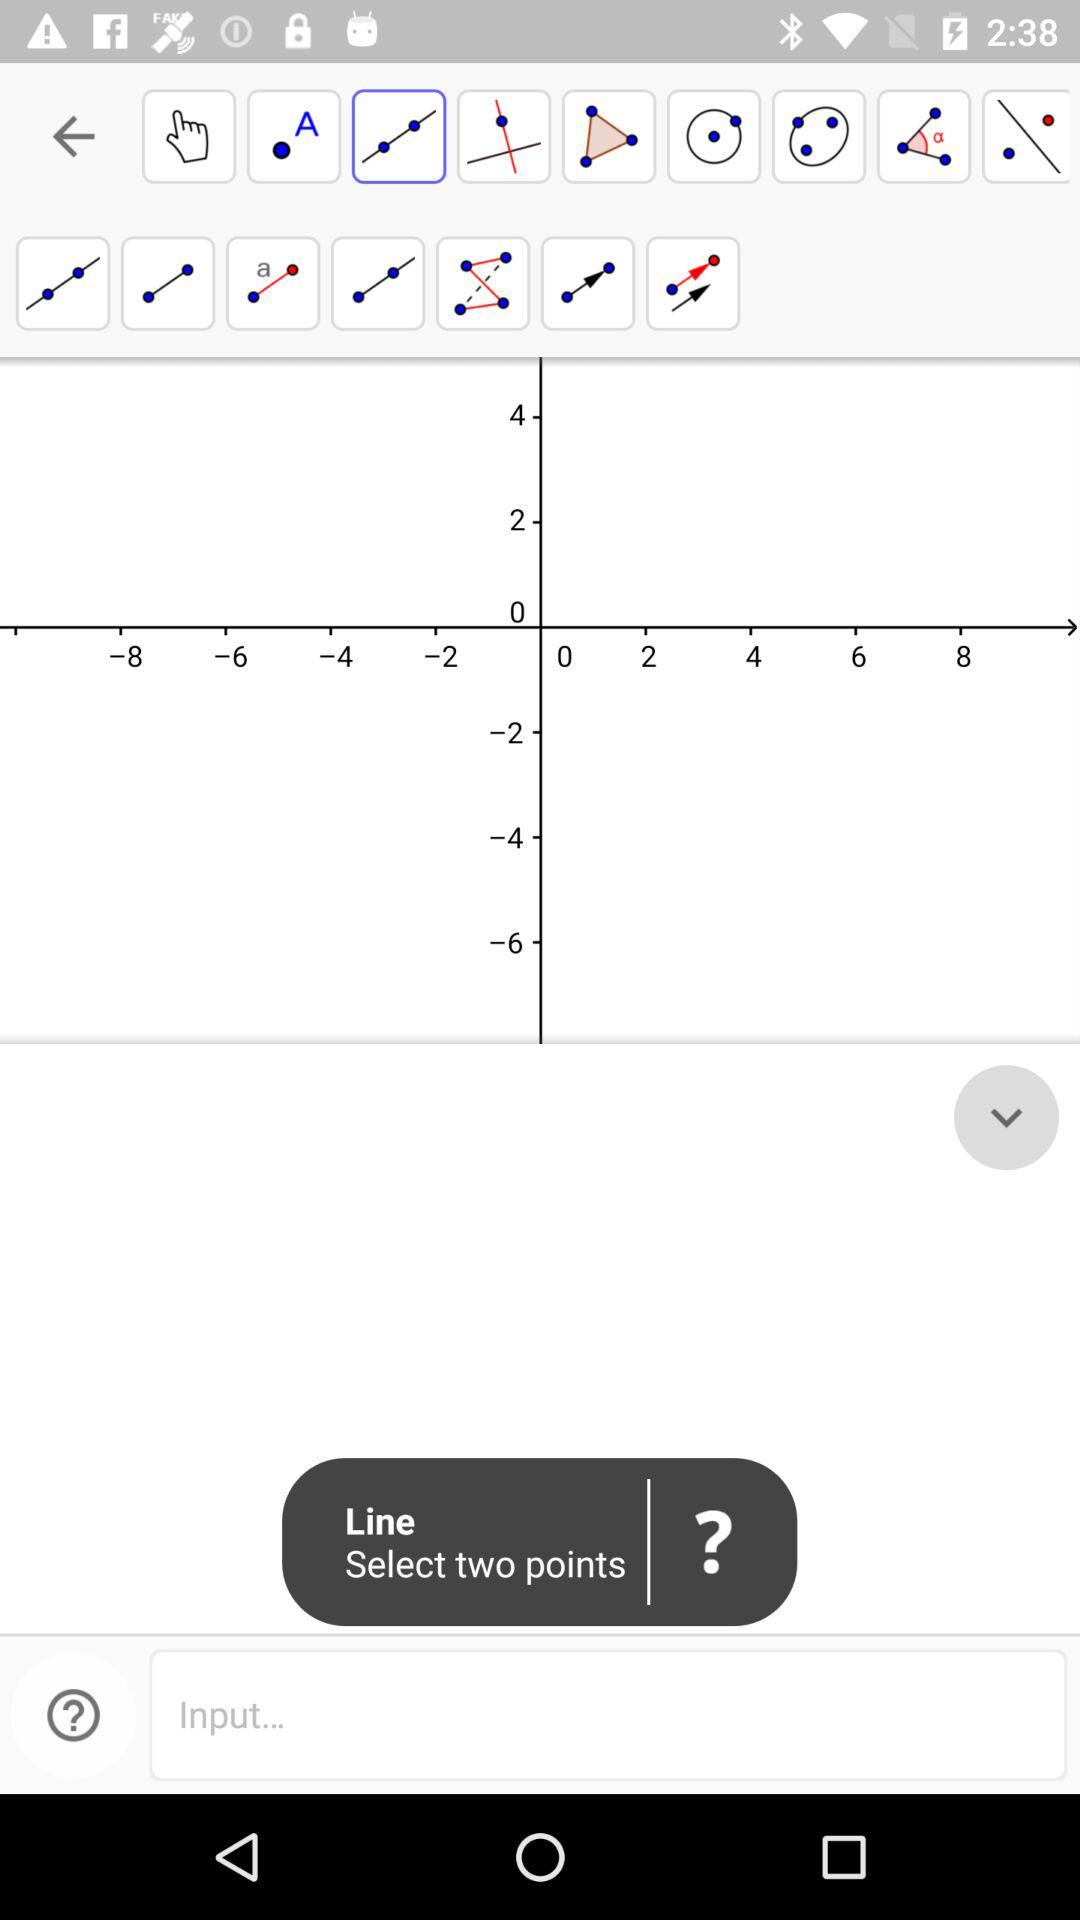How many points do I have to select? You have to select two points. 